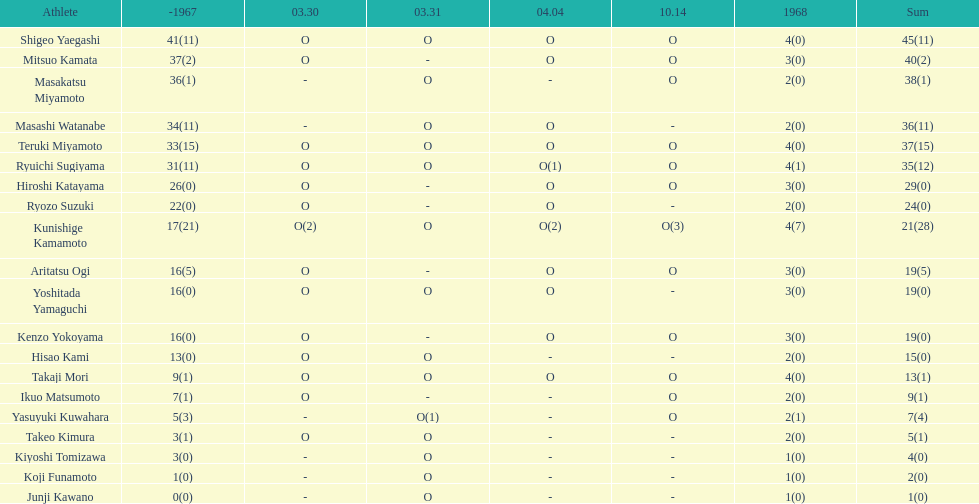Did mitsuo kamata have more than 40 total points? No. 